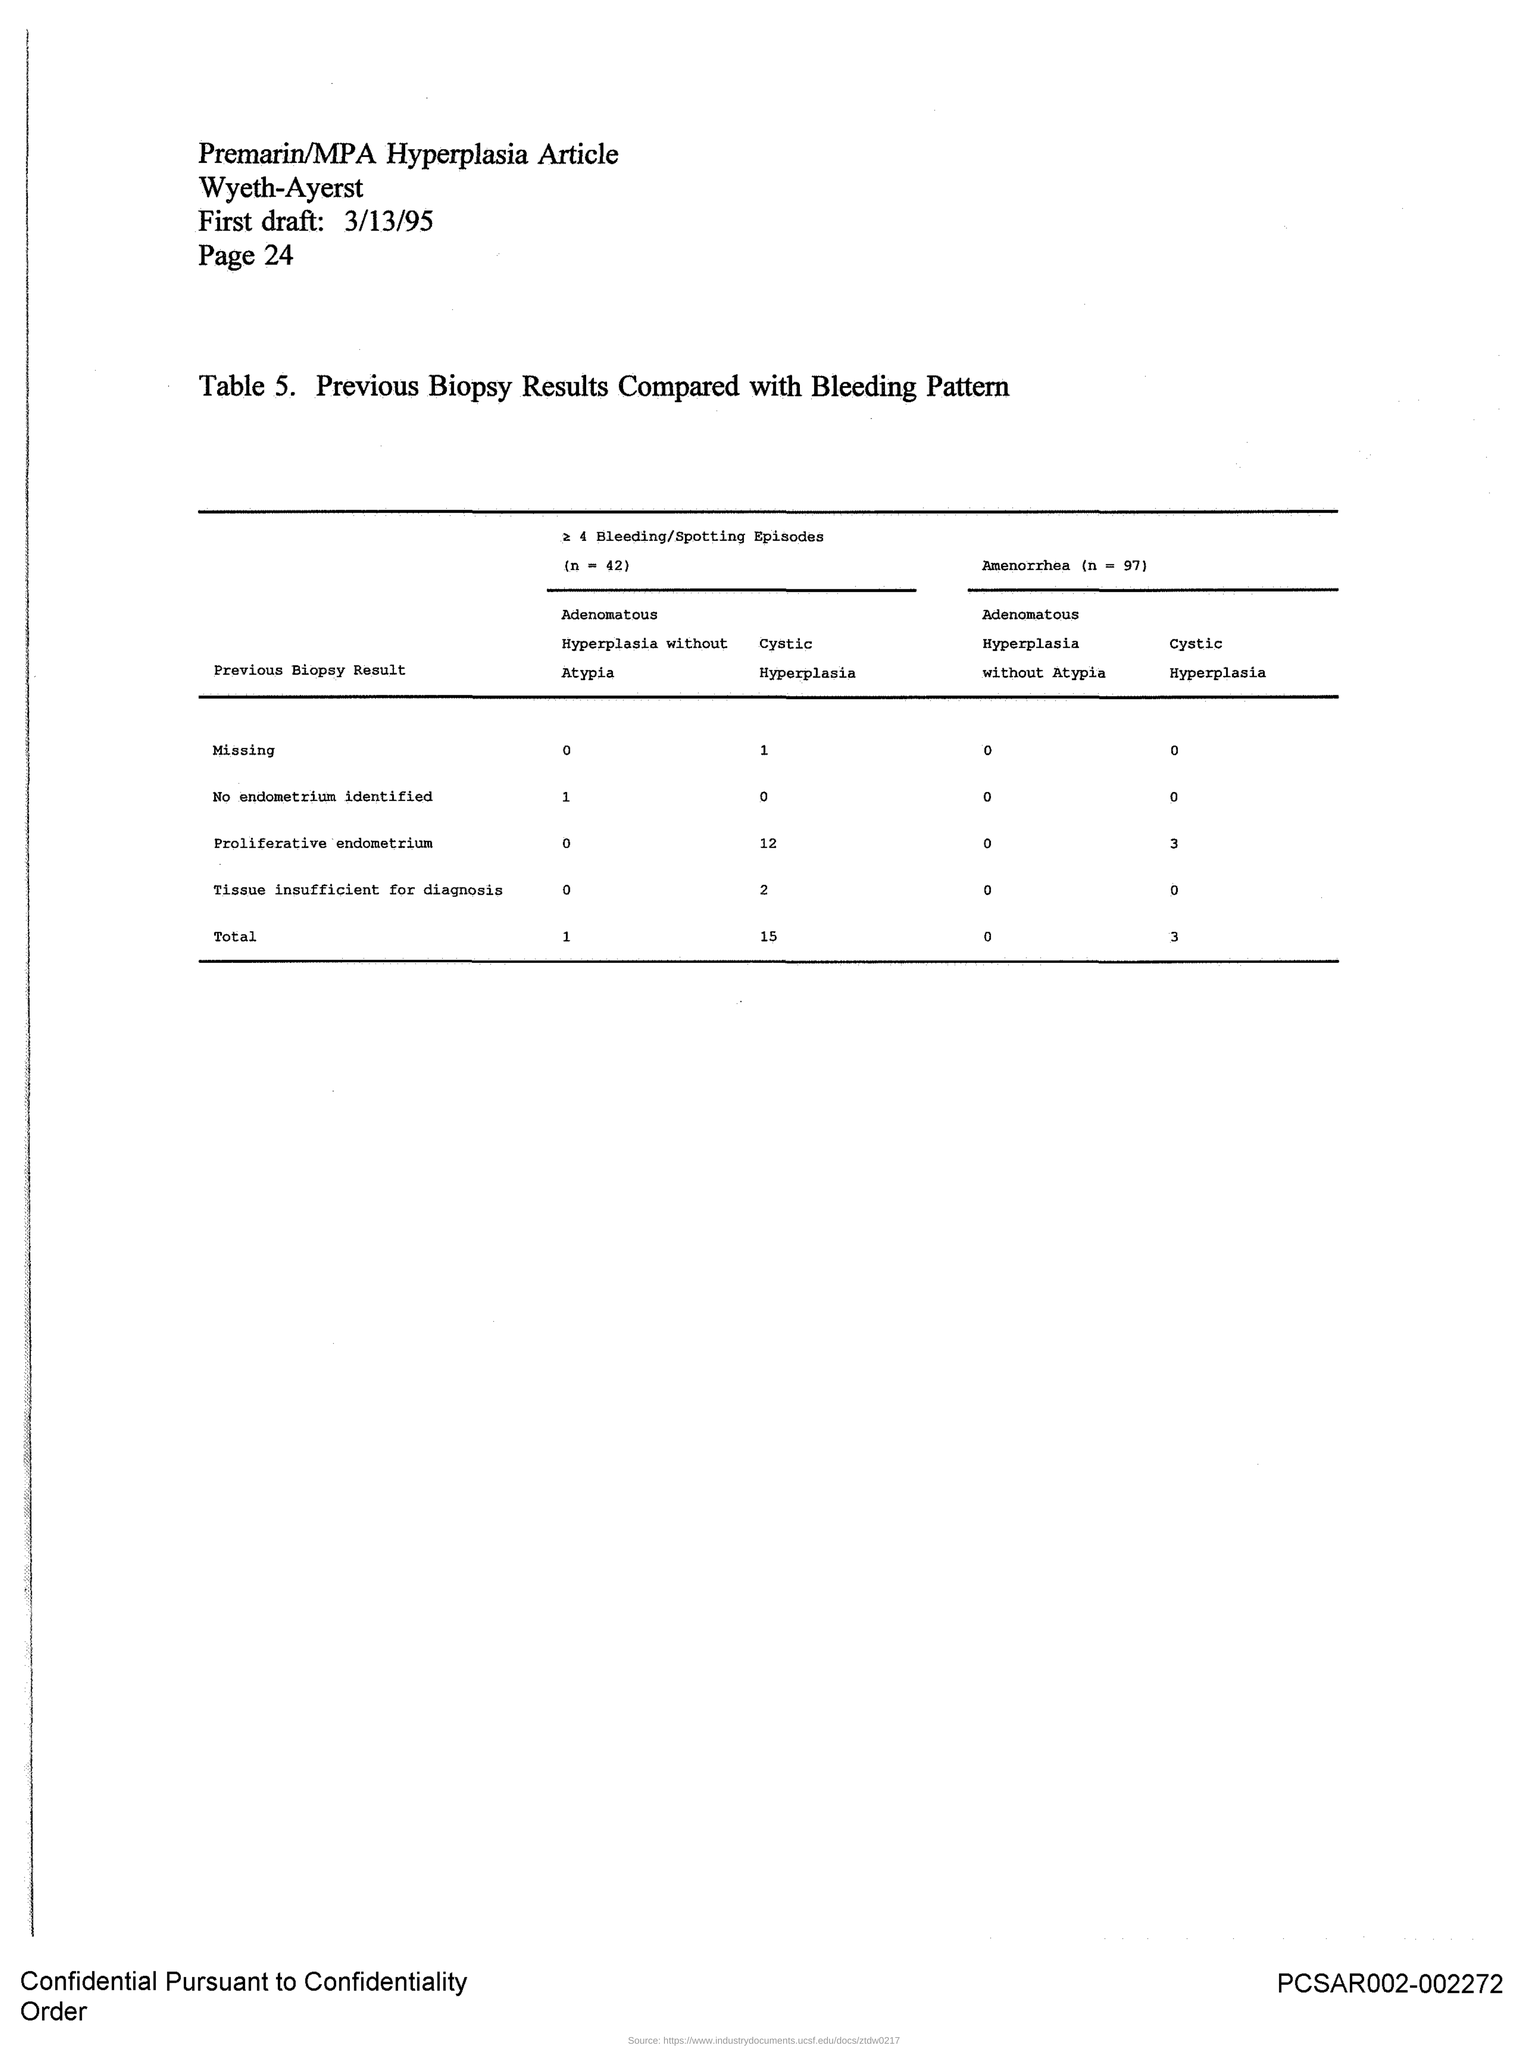What does Table 5. describe about?
Ensure brevity in your answer.  Previous Biopsy Results Compared with Bleeding Pattern. What is the page no mentioned in this document?
Give a very brief answer. 24. What is the first draft date given in the document?
Ensure brevity in your answer.  3/13/95. Which article is mentioned in the document?
Provide a short and direct response. Premarin/MPA Hyperplasia Article. 